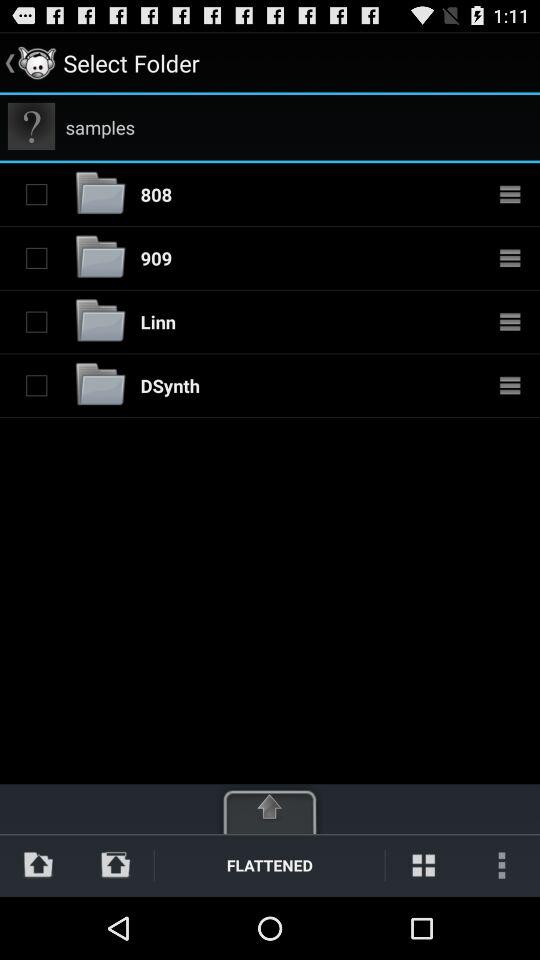What is the status of folder named 808? The status is off. 